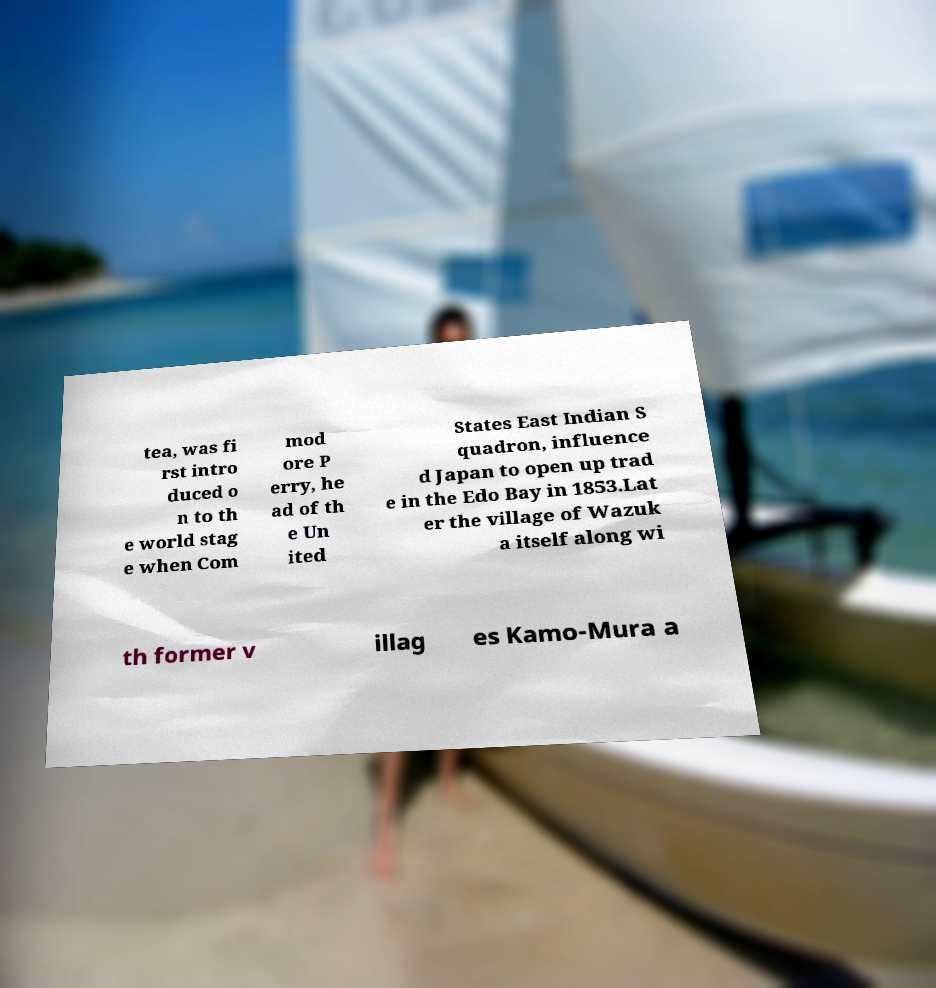Can you read and provide the text displayed in the image?This photo seems to have some interesting text. Can you extract and type it out for me? tea, was fi rst intro duced o n to th e world stag e when Com mod ore P erry, he ad of th e Un ited States East Indian S quadron, influence d Japan to open up trad e in the Edo Bay in 1853.Lat er the village of Wazuk a itself along wi th former v illag es Kamo-Mura a 